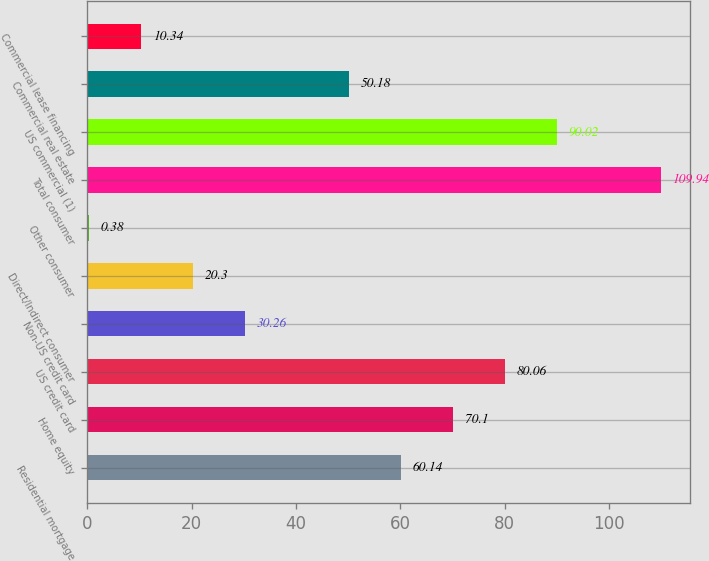Convert chart. <chart><loc_0><loc_0><loc_500><loc_500><bar_chart><fcel>Residential mortgage<fcel>Home equity<fcel>US credit card<fcel>Non-US credit card<fcel>Direct/Indirect consumer<fcel>Other consumer<fcel>Total consumer<fcel>US commercial (1)<fcel>Commercial real estate<fcel>Commercial lease financing<nl><fcel>60.14<fcel>70.1<fcel>80.06<fcel>30.26<fcel>20.3<fcel>0.38<fcel>109.94<fcel>90.02<fcel>50.18<fcel>10.34<nl></chart> 